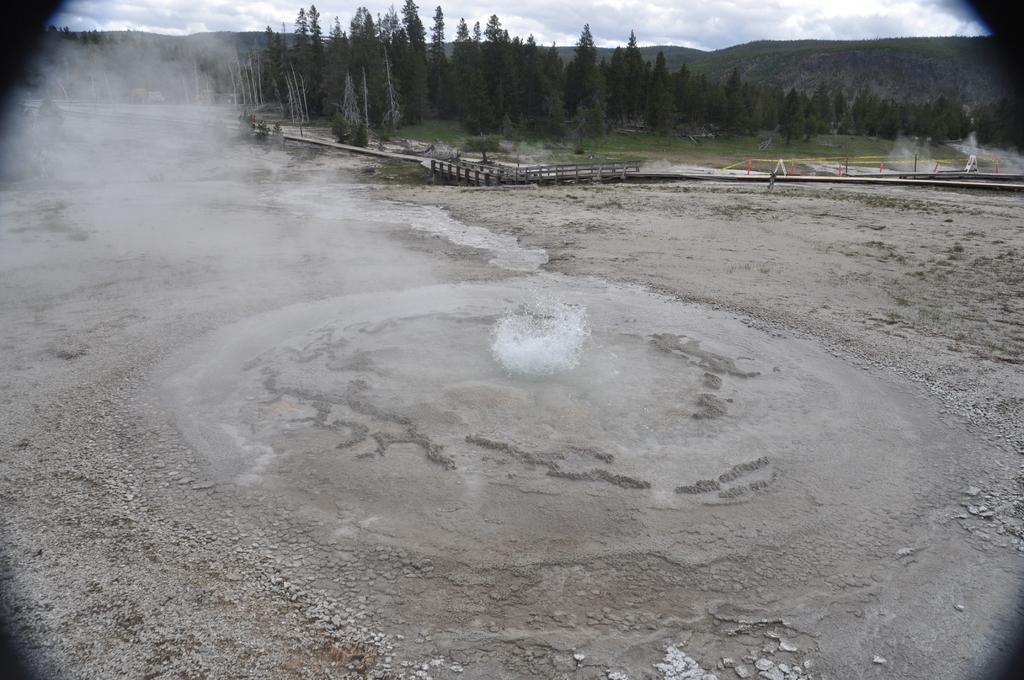How would you summarize this image in a sentence or two? In this image there is a soil ground in the bottom of this image and there are some trees in the background. There is a sky on the top of this image. 